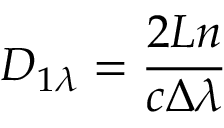Convert formula to latex. <formula><loc_0><loc_0><loc_500><loc_500>D _ { 1 \lambda } = \frac { 2 L n } { c \Delta \lambda }</formula> 